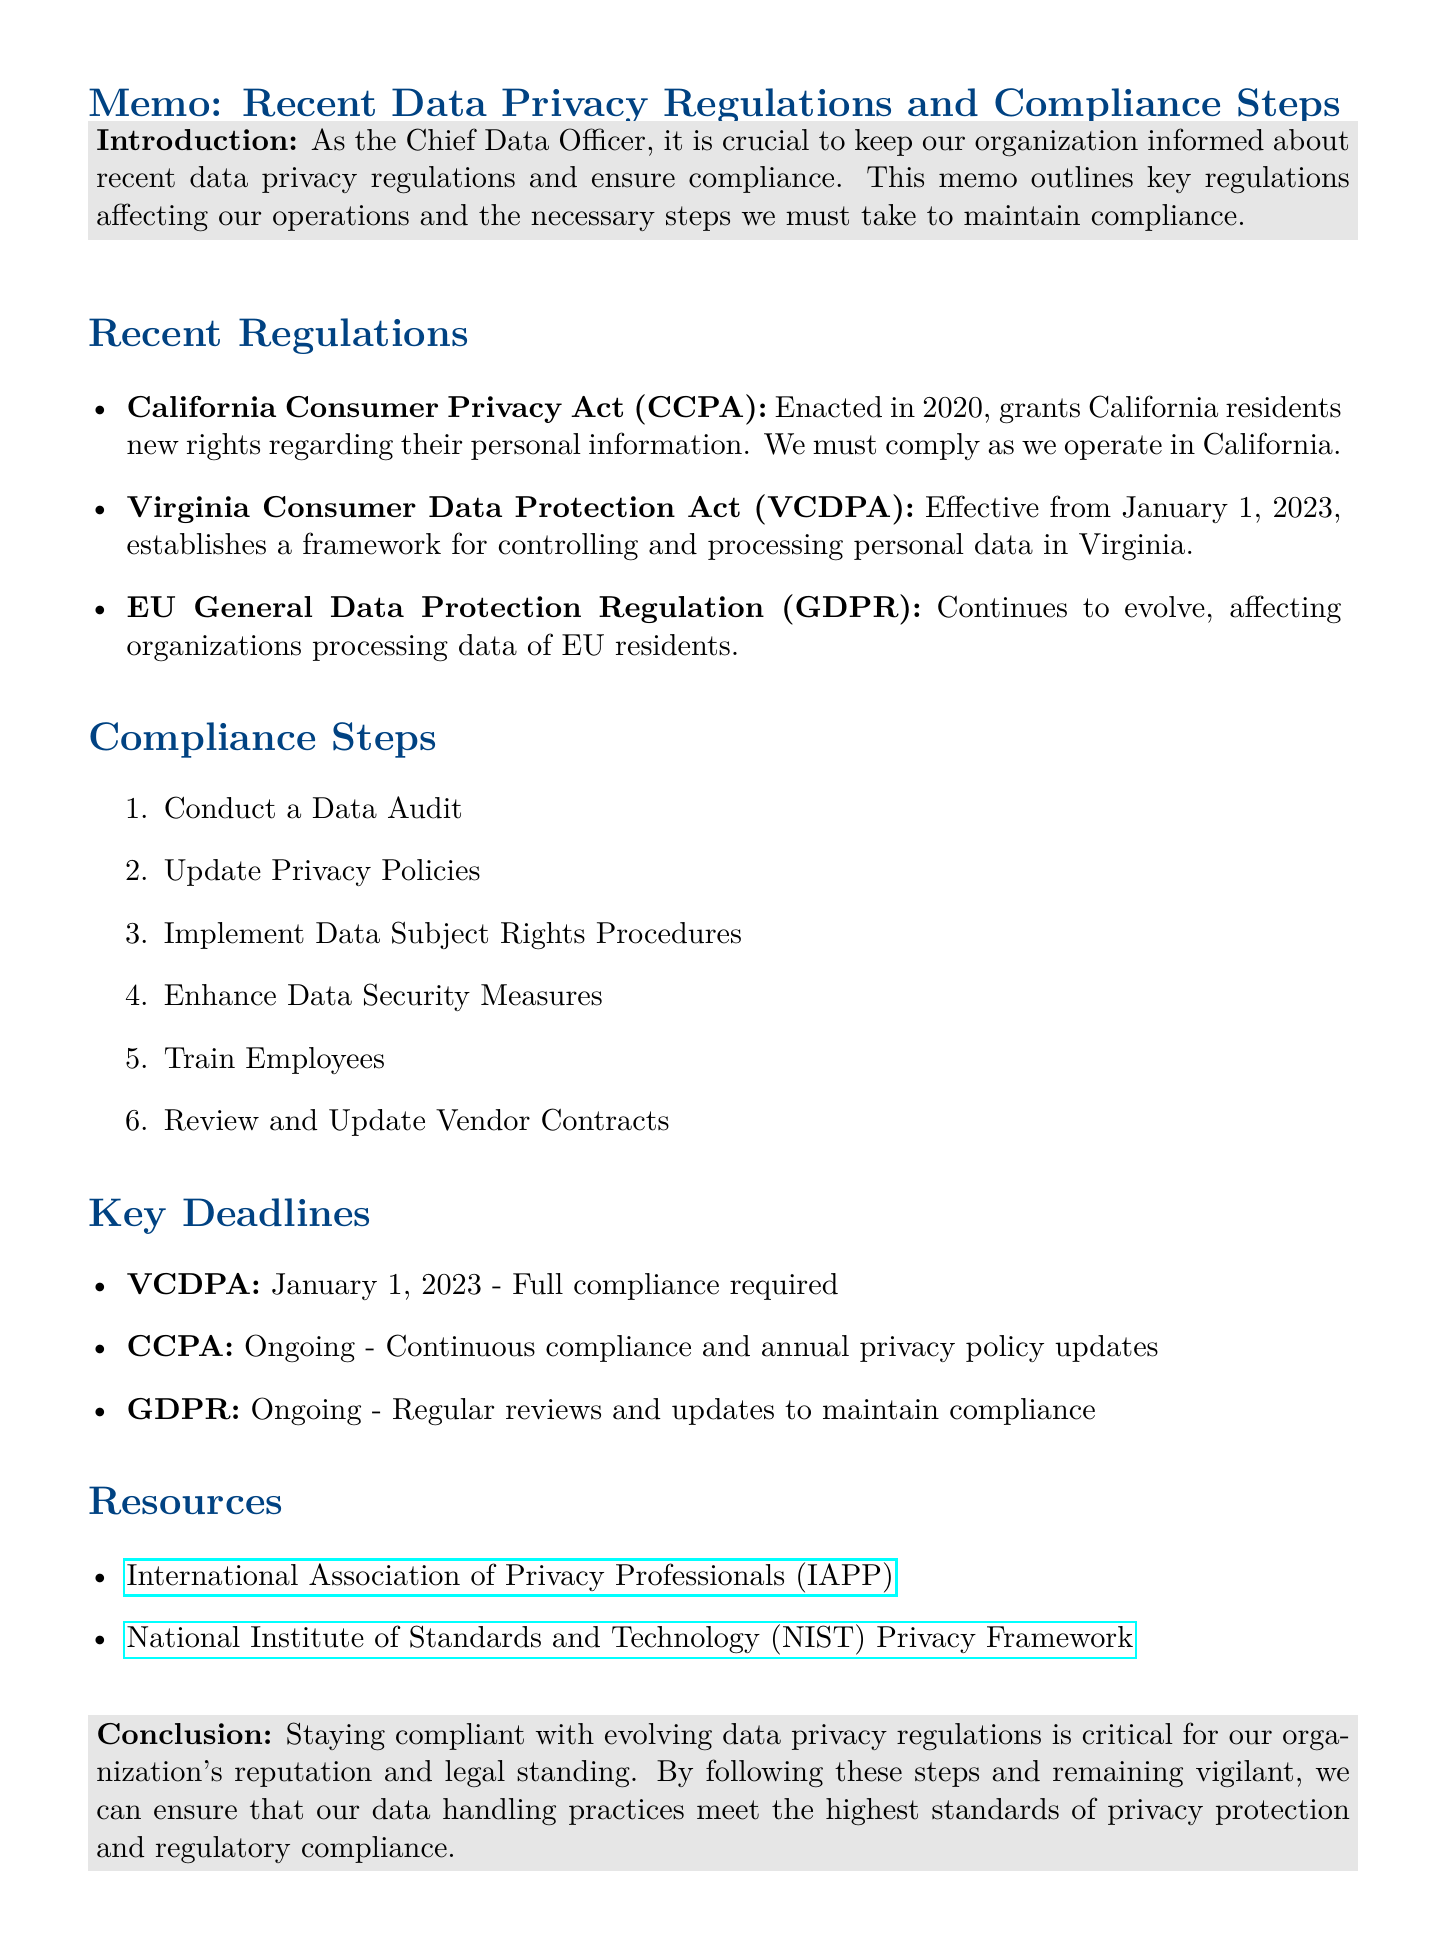What is the title of the memo? The title is stated at the beginning of the memo as "Recent Data Privacy Regulations and Compliance Steps."
Answer: Recent Data Privacy Regulations and Compliance Steps Who is the memo addressed to? The memo specifically identifies the author as the Chief Data Officer but does not mention a specific recipient, indicating it could be for internal use regarding data privacy compliance.
Answer: Chief Data Officer What is the effective date of the VCDPA? The memo mentions that the VCDPA became effective from January 1, 2023.
Answer: January 1, 2023 What is one of the compliance steps listed in the memo? The memo outlines several compliance steps, one of which includes "Conduct a Data Audit."
Answer: Conduct a Data Audit What organization provides information on global privacy regulations? The memo lists the International Association of Privacy Professionals (IAPP) as a resource for information on global privacy regulations.
Answer: International Association of Privacy Professionals (IAPP) How often must the CCPA compliance be reviewed? The memo states that compliance with CCPA is ongoing, along with annual privacy policy updates.
Answer: Ongoing What is required for GDPR compliance according to the memo? The memo emphasizes that regular reviews and updates are necessary to maintain compliance with GDPR.
Answer: Regular reviews and updates What is a key deadline for CCPA? The memo notes that CCPA compliance is ongoing with a specific emphasis on continuous compliance.
Answer: Ongoing How many compliance steps are listed in the document? The compliance section provides a list, which can be counted to find there are six specific steps mentioned.
Answer: Six 